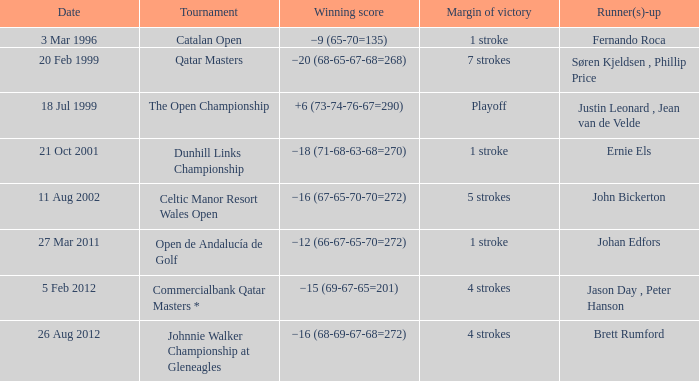Fernando roca was the runner-up in which tournament? Catalan Open. 